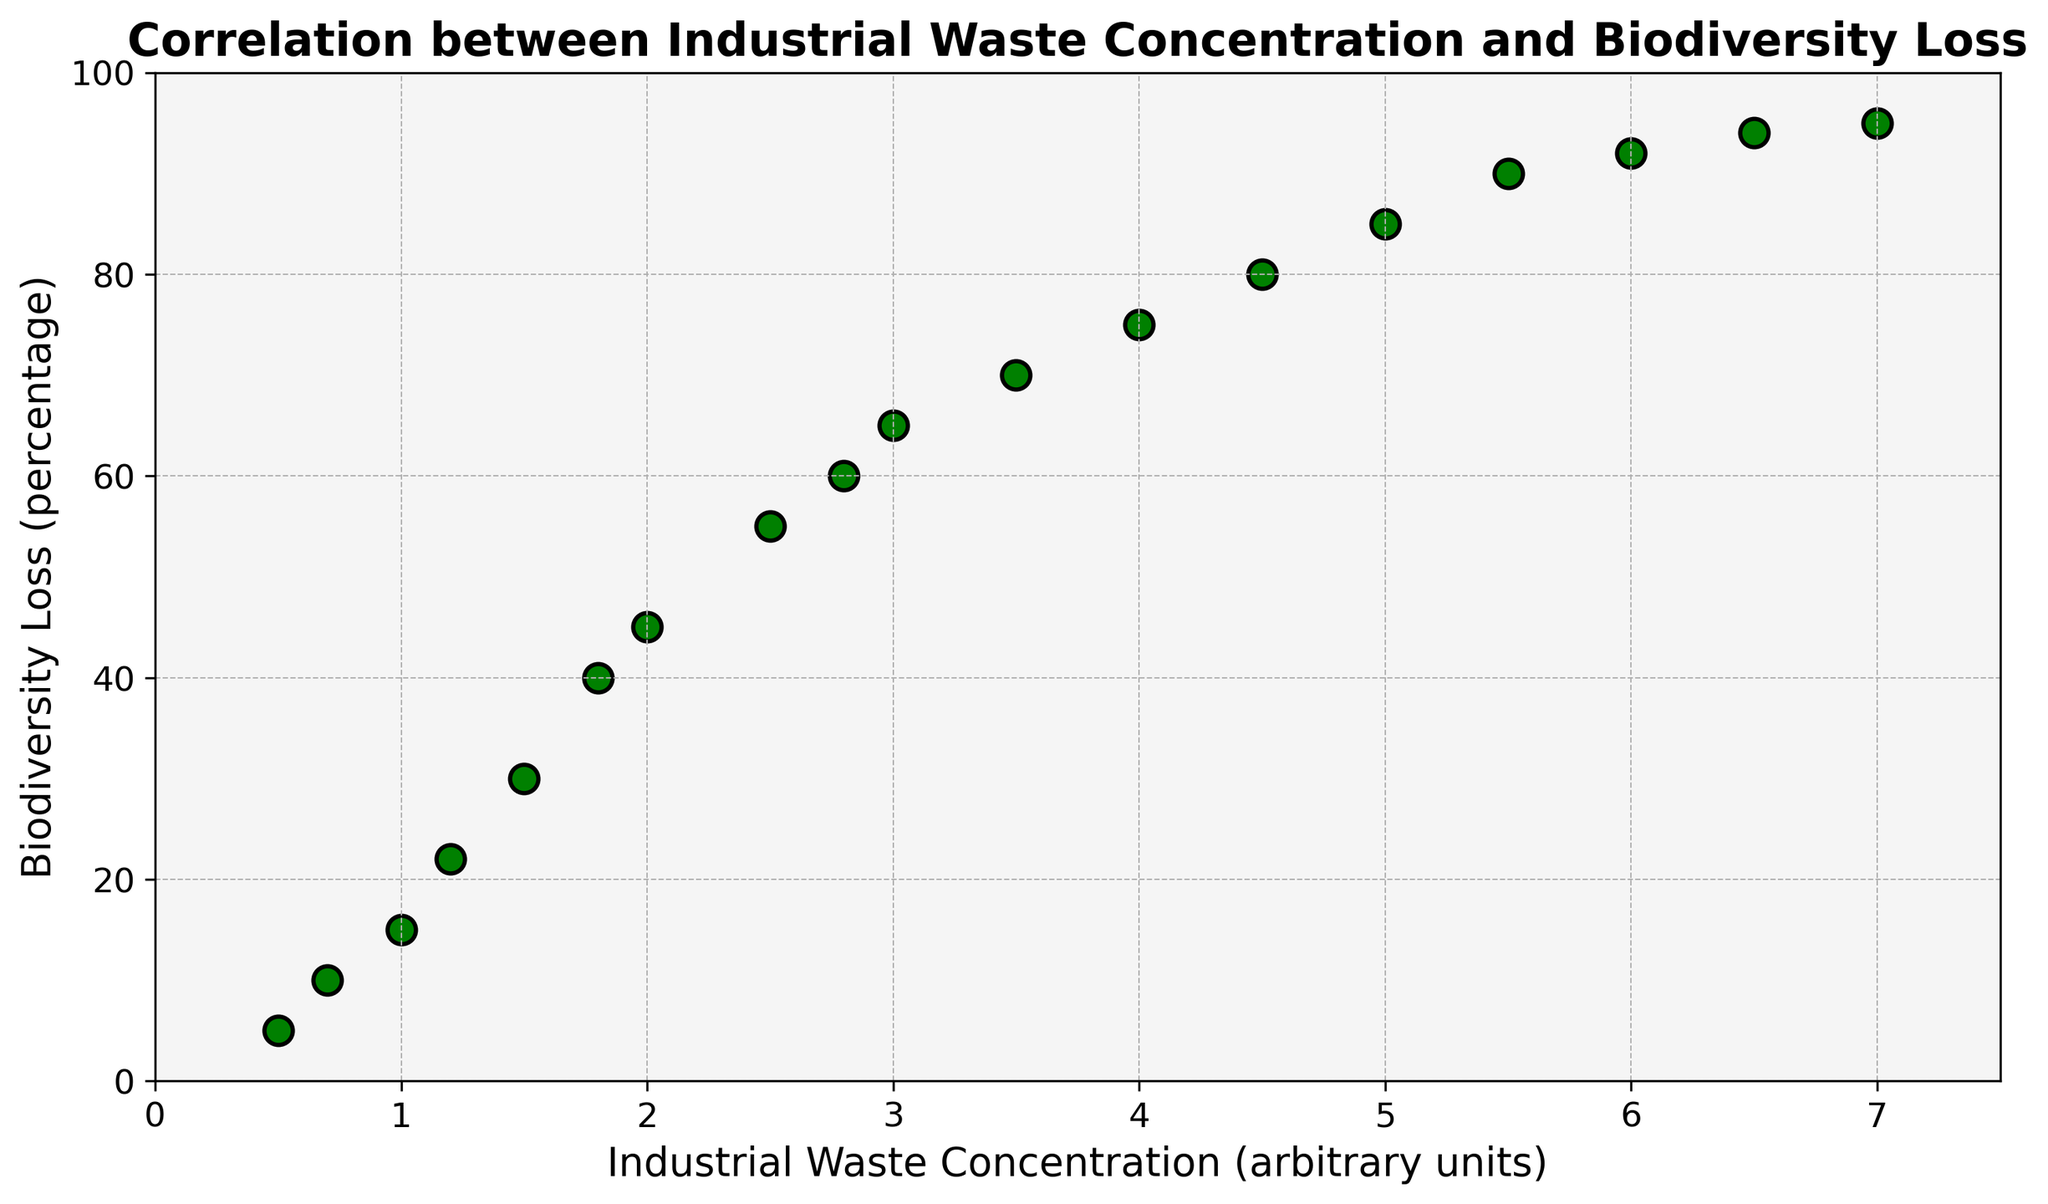Which data point shows the highest biodiversity loss? By visually inspecting the scatter plot, it is clear that the data point at the highest position on the y-axis indicates the highest biodiversity loss. This point corresponds to an industrial waste concentration of 7.0 units.
Answer: 95% How does biodiversity loss change as industrial waste concentration increases from 1.0 to 3.0 units? To answer this, look at the data points for 1.0 and 3.0 units of industrial waste concentration and compare their y-values. The biodiversity loss increases from 15% to 65%, indicating a significant rise.
Answer: Increases significantly Compare the biodiversity loss at waste concentrations of 2.0 and 5.0 units. Which is higher and by how much? Refer to the y-values for 2.0 units (45%) and 5.0 units (85%). Biodiversity loss at 5.0 units is higher. Subtract 45% from 85% to find the difference: 85% - 45% = 40%.
Answer: 85% is higher by 40% Determine the average biodiversity loss for industrial waste concentrations between 2.0 and 4.0 units. Select the points for concentrations of 2.0, 2.5, 2.8, 3.0, 3.5, and 4.0 units. Their respective biodiversity losses are 45%, 55%, 60%, 65%, 70%, and 75%. Sum these values and divide by the number of points: (45 + 55 + 60 + 65 + 70 + 75) / 6 = 61.67%.
Answer: 61.67% What is the biodiversity loss when the industrial waste concentration is 6.0 units? Locate the data point where the x-value is 6.0 units. The corresponding y-value is 92%, which indicates the biodiversity loss.
Answer: 92% Identify the trend in biodiversity loss beyond an industrial waste concentration of 4.5 units. Is the increase linear, exponential, or plateauing? Observing points beyond 4.5 units until the maximum value of 7.0, the increase in biodiversity loss appears to be slowing down, suggesting a plateau rather than a linear or exponential increase.
Answer: Plateauing How much is the biodiversity loss at an industrial waste concentration of 0.7 units? Refer to the scatter point at x = 0.7 units. The corresponding y-value is 10%.
Answer: 10% What is the difference in biodiversity loss between industrial waste concentrations of 2.8 and 3.5 units? Look at the y-values for 2.8 units (60%) and 3.5 units (70%). Subtract 60% from 70% to find the difference: 70% - 60% = 10%.
Answer: 10% Between which concentrations does the biodiversity loss increase by the largest amount? By comparing successive data points, the largest increase in biodiversity loss is observed between concentrations of 1.8 units (40%) and 2.0 units (45%). The increase is 5%.
Answer: Between 1.8 and 2.0 units 